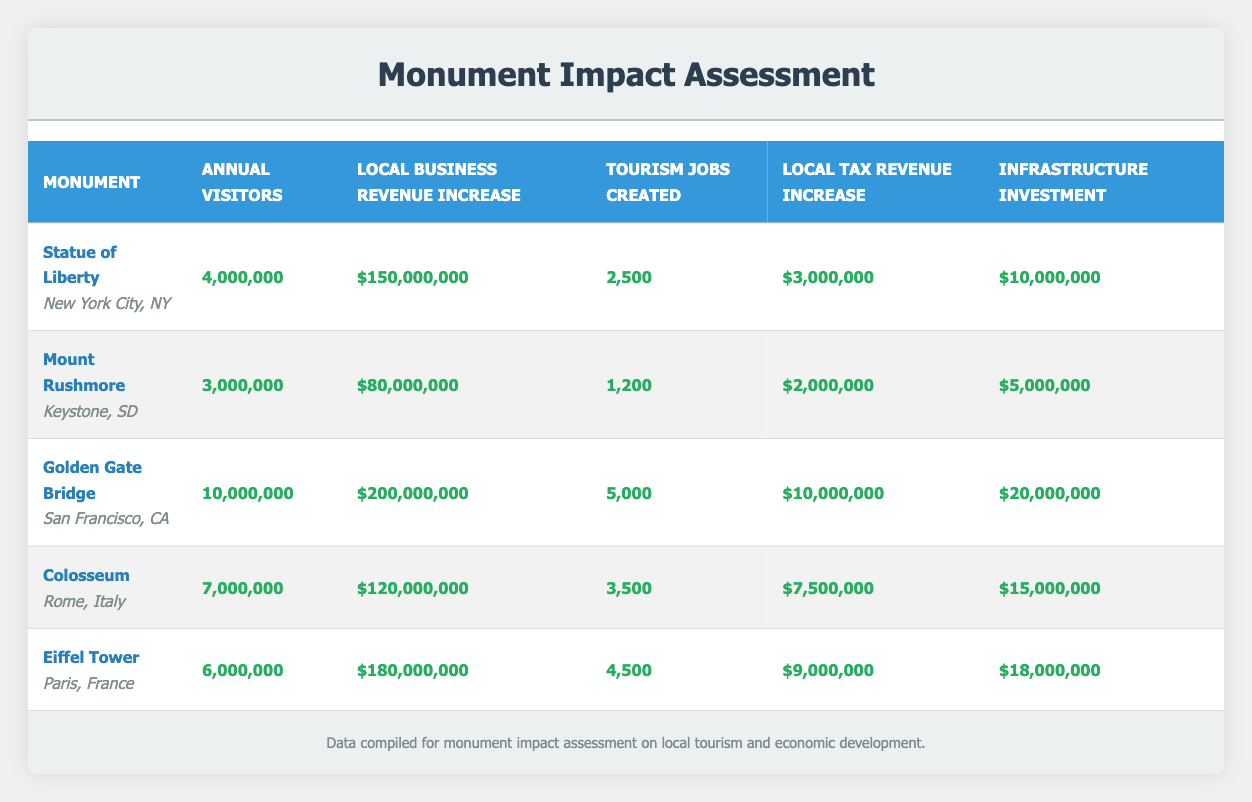What is the annual visitor count for the Golden Gate Bridge? The table indicates that the Golden Gate Bridge has an annual visitor count of 10,000,000. This value is directly found in the corresponding row under the "Annual Visitors" column.
Answer: 10,000,000 Which monument has the highest local business revenue increase? By reviewing the "Local Business Revenue Increase" column, the Golden Gate Bridge shows the highest increase at $200,000,000, while other monuments have lower revenue increases, making it clear that the Golden Gate Bridge leads in this metric.
Answer: Golden Gate Bridge What is the total number of tourism-related jobs created among all listed monuments? To find the total number of tourism-related jobs created, we add the values: 2,500 (Statue of Liberty) + 1,200 (Mount Rushmore) + 5,000 (Golden Gate Bridge) + 3,500 (Colosseum) + 4,500 (Eiffel Tower) = 16,700. Therefore, the total jobs created is 16,700.
Answer: 16,700 Does the Colosseum have more annual visitors than the Statue of Liberty? The Colosseum has 7,000,000 annual visitors while the Statue of Liberty has 4,000,000. Since 7,000,000 is greater than 4,000,000, this statement is true.
Answer: Yes What is the investment in infrastructure of Mount Rushmore compared to the Eiffel Tower? The investment in infrastructure for Mount Rushmore is $5,000,000, while for the Eiffel Tower, it is $18,000,000. Since $5,000,000 is less than $18,000,000, therefore, Mount Rushmore has less investment in infrastructure.
Answer: Mount Rushmore has less investment What is the average local tax revenue increase of the monuments listed? To calculate the average local tax revenue increase, we first sum the values: $3,000,000 (Statue of Liberty) + $2,000,000 (Mount Rushmore) + $10,000,000 (Golden Gate Bridge) + $7,500,000 (Colosseum) + $9,000,000 (Eiffel Tower) = $31,500,000. Then, we divide by the number of monuments (5), resulting in an average of $6,300,000.
Answer: $6,300,000 Which monument creates the least number of tourism jobs? The table shows that Mount Rushmore generates 1,200 tourism-related jobs, which is the lowest figure compared to the other monuments listed, confirming it creates the least number of jobs.
Answer: Mount Rushmore Is the increase in local tax revenue for the Statue of Liberty greater than that of the Colosseum? The increase in local tax revenue for the Statue of Liberty is $3,000,000, while for the Colosseum it is $7,500,000. Since $3,000,000 is less than $7,500,000, this statement is false.
Answer: No 